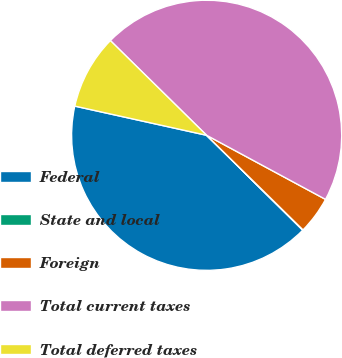Convert chart to OTSL. <chart><loc_0><loc_0><loc_500><loc_500><pie_chart><fcel>Federal<fcel>State and local<fcel>Foreign<fcel>Total current taxes<fcel>Total deferred taxes<nl><fcel>41.07%<fcel>0.05%<fcel>4.48%<fcel>45.5%<fcel>8.9%<nl></chart> 